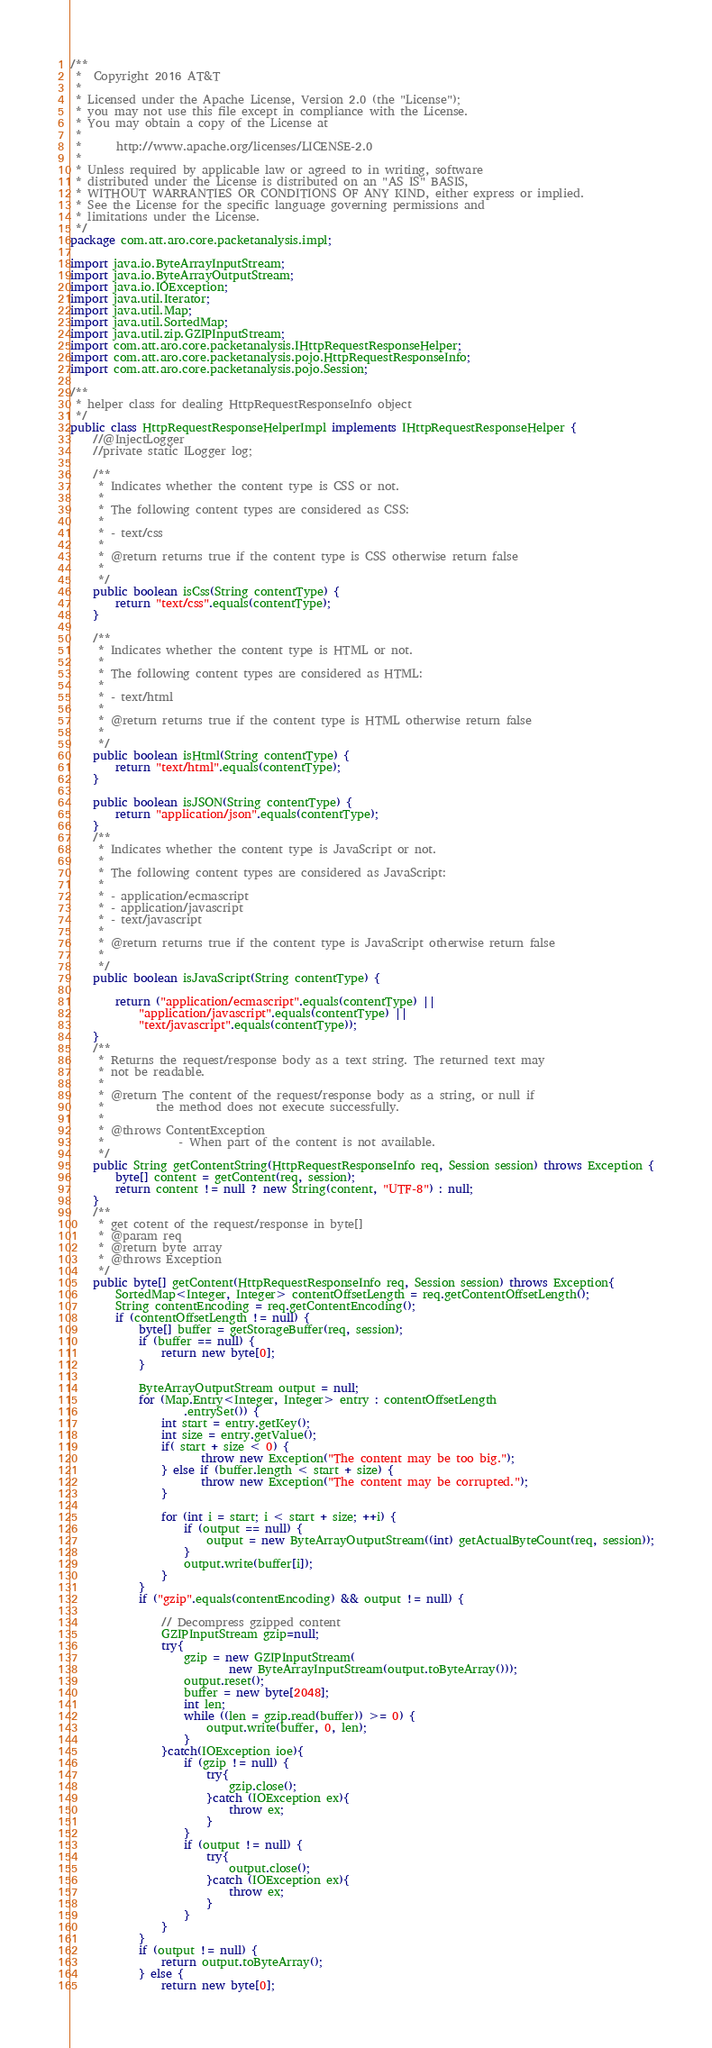Convert code to text. <code><loc_0><loc_0><loc_500><loc_500><_Java_>/**
 *  Copyright 2016 AT&T
 *
 * Licensed under the Apache License, Version 2.0 (the "License");
 * you may not use this file except in compliance with the License.
 * You may obtain a copy of the License at
 *
 *      http://www.apache.org/licenses/LICENSE-2.0
 *
 * Unless required by applicable law or agreed to in writing, software
 * distributed under the License is distributed on an "AS IS" BASIS,
 * WITHOUT WARRANTIES OR CONDITIONS OF ANY KIND, either express or implied.
 * See the License for the specific language governing permissions and
 * limitations under the License.
 */
package com.att.aro.core.packetanalysis.impl;

import java.io.ByteArrayInputStream;
import java.io.ByteArrayOutputStream;
import java.io.IOException;
import java.util.Iterator;
import java.util.Map;
import java.util.SortedMap;
import java.util.zip.GZIPInputStream;
import com.att.aro.core.packetanalysis.IHttpRequestResponseHelper;
import com.att.aro.core.packetanalysis.pojo.HttpRequestResponseInfo;
import com.att.aro.core.packetanalysis.pojo.Session;

/**
 * helper class for dealing HttpRequestResponseInfo object
 */
public class HttpRequestResponseHelperImpl implements IHttpRequestResponseHelper {
	//@InjectLogger
	//private static ILogger log;
	
	/**
	 * Indicates whether the content type is CSS or not.
	 * 
	 * The following content types are considered as CSS:
	 * 
	 * - text/css
	 * 
	 * @return returns true if the content type is CSS otherwise return false
	 * 
	 */
	public boolean isCss(String contentType) {
		return "text/css".equals(contentType);
	}
	
	/**
	 * Indicates whether the content type is HTML or not.
	 * 
	 * The following content types are considered as HTML:
	 * 
	 * - text/html
	 * 
	 * @return returns true if the content type is HTML otherwise return false
	 * 
	 */
	public boolean isHtml(String contentType) {
		return "text/html".equals(contentType);
	}

	public boolean isJSON(String contentType) {
		return "application/json".equals(contentType);
	}
	/**
	 * Indicates whether the content type is JavaScript or not.
	 * 
	 * The following content types are considered as JavaScript:
	 * 
	 * - application/ecmascript
	 * - application/javascript
	 * - text/javascript
	 * 
	 * @return returns true if the content type is JavaScript otherwise return false
	 * 
	 */
	public boolean isJavaScript(String contentType) {

		return ("application/ecmascript".equals(contentType) ||
			"application/javascript".equals(contentType) ||
			"text/javascript".equals(contentType));
	}
	/**
	 * Returns the request/response body as a text string. The returned text may
	 * not be readable.
	 * 
	 * @return The content of the request/response body as a string, or null if
	 *         the method does not execute successfully.
	 * 
	 * @throws ContentException
	 *             - When part of the content is not available.
	 */
	public String getContentString(HttpRequestResponseInfo req, Session session) throws Exception {
		byte[] content = getContent(req, session);
		return content != null ? new String(content, "UTF-8") : null;
	}
	/**
	 * get cotent of the request/response in byte[]
	 * @param req
	 * @return byte array
	 * @throws Exception 
	 */
	public byte[] getContent(HttpRequestResponseInfo req, Session session) throws Exception{
		SortedMap<Integer, Integer> contentOffsetLength = req.getContentOffsetLength();
		String contentEncoding = req.getContentEncoding();
		if (contentOffsetLength != null) {
			byte[] buffer = getStorageBuffer(req, session);
			if (buffer == null) {
				return new byte[0];
			}
			
			ByteArrayOutputStream output = null;
			for (Map.Entry<Integer, Integer> entry : contentOffsetLength
					.entrySet()) {
				int start = entry.getKey();
				int size = entry.getValue();
				if( start + size < 0) {
				       throw new Exception("The content may be too big.");
				} else if (buffer.length < start + size) {
				       throw new Exception("The content may be corrupted.");
				}

				for (int i = start; i < start + size; ++i) {
				    if (output == null) {
				        output = new ByteArrayOutputStream((int) getActualByteCount(req, session));
				    }
					output.write(buffer[i]);
				}
			}
			if ("gzip".equals(contentEncoding) && output != null) {

				// Decompress gzipped content
				GZIPInputStream gzip=null;
				try{
					gzip = new GZIPInputStream(
							new ByteArrayInputStream(output.toByteArray()));
					output.reset();
					buffer = new byte[2048];
					int len;
					while ((len = gzip.read(buffer)) >= 0) {
						output.write(buffer, 0, len);
					}
				}catch(IOException ioe){
					if (gzip != null) {
						try{
							gzip.close();
						}catch (IOException ex){
							throw ex;
						}
					}
					if (output != null) {
						try{
							output.close();
						}catch (IOException ex){
							throw ex;
						}
					}
				}
			}
			if (output != null) {
			    return output.toByteArray();
			} else {
			    return new byte[0];</code> 